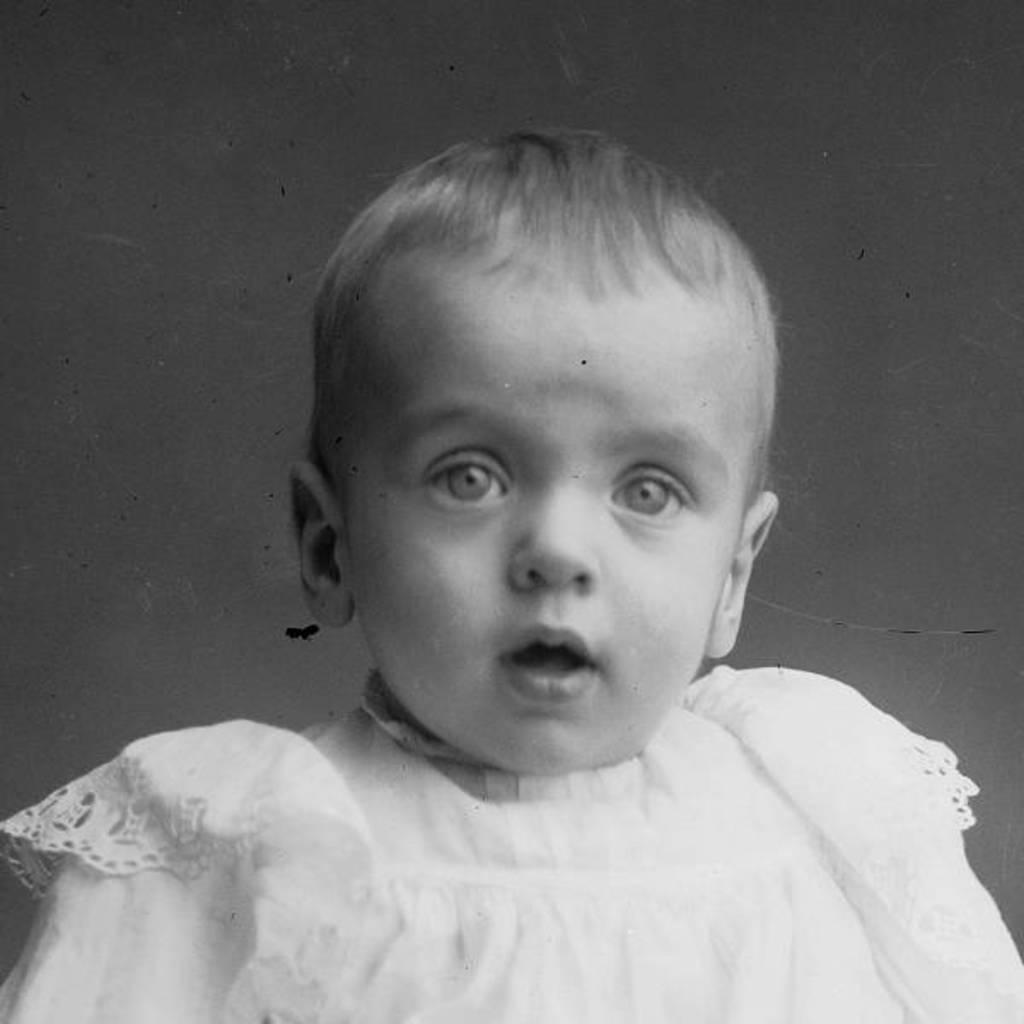What is the color scheme of the image? The image is black and white. What is the main subject of the image? There is a kid in the middle of the image. What is the kid wearing? The kid is wearing a white dress. What rule does the stranger break in the image? There is no stranger present in the image, so it is not possible to determine if any rules are broken. 